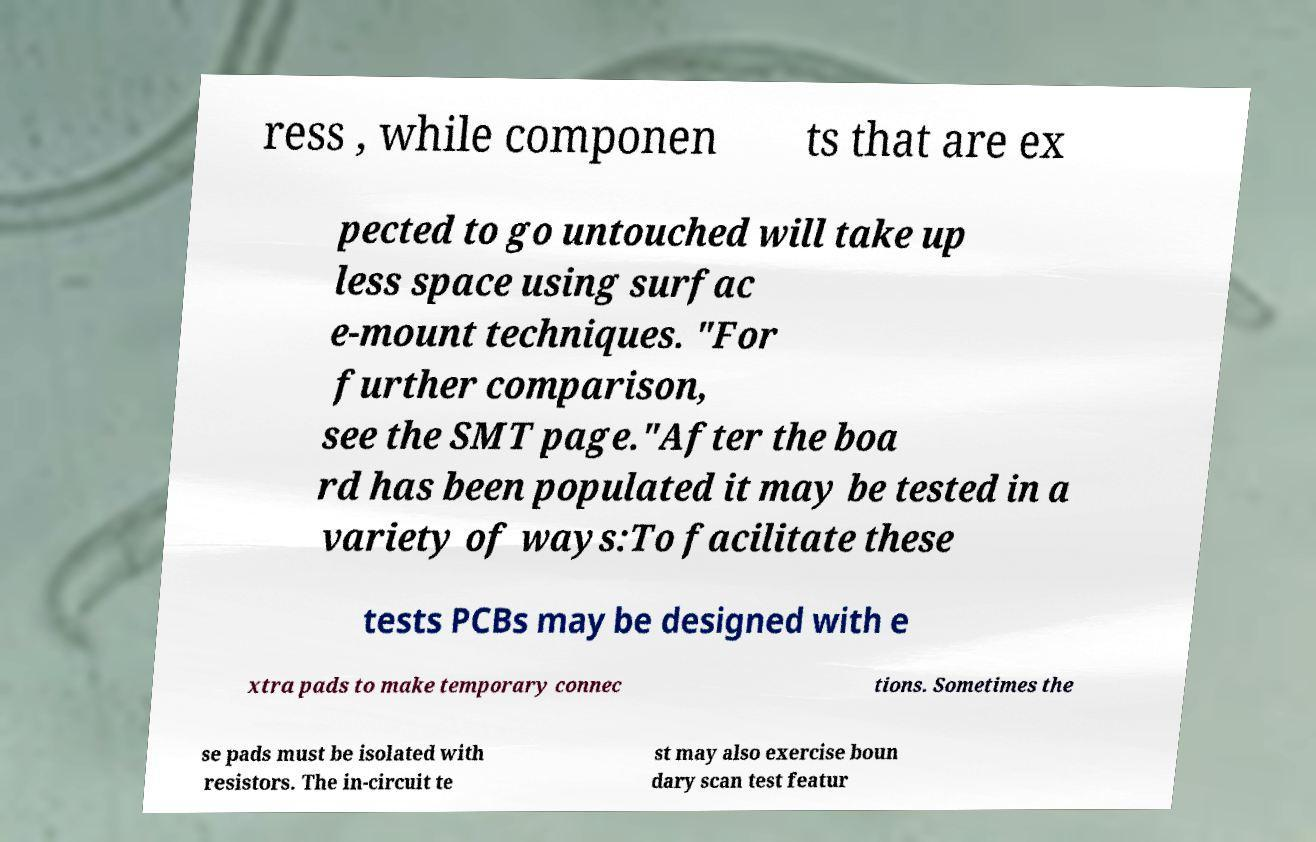I need the written content from this picture converted into text. Can you do that? ress , while componen ts that are ex pected to go untouched will take up less space using surfac e-mount techniques. "For further comparison, see the SMT page."After the boa rd has been populated it may be tested in a variety of ways:To facilitate these tests PCBs may be designed with e xtra pads to make temporary connec tions. Sometimes the se pads must be isolated with resistors. The in-circuit te st may also exercise boun dary scan test featur 